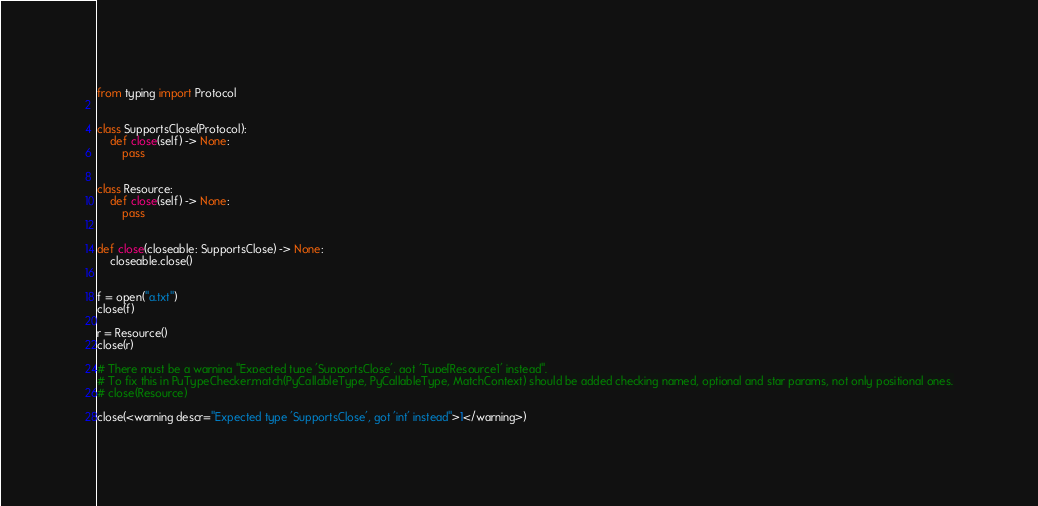Convert code to text. <code><loc_0><loc_0><loc_500><loc_500><_Python_>from typing import Protocol


class SupportsClose(Protocol):
    def close(self) -> None:
        pass


class Resource:
    def close(self) -> None:
        pass


def close(closeable: SupportsClose) -> None:
    closeable.close()


f = open("a.txt")
close(f)

r = Resource()
close(r)

# There must be a warning "Expected type 'SupportsClose', got 'Type[Resource]' instead".
# To fix this in PyTypeChecker.match(PyCallableType, PyCallableType, MatchContext) should be added checking named, optional and star params, not only positional ones.
# close(Resource)

close(<warning descr="Expected type 'SupportsClose', got 'int' instead">1</warning>)
</code> 